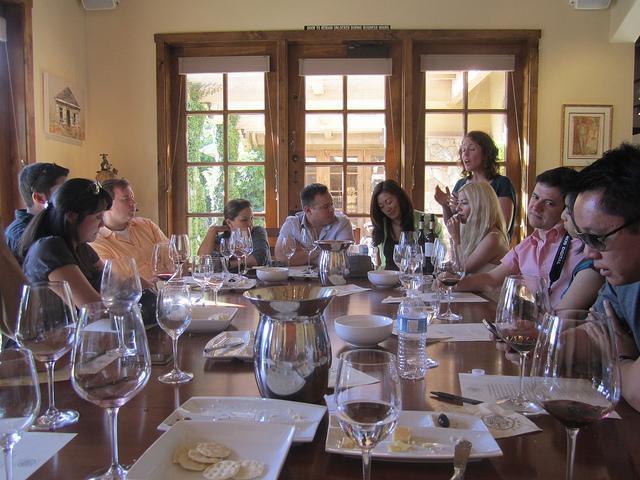How many windows are there?
Give a very brief answer. 3. How many people are in the picture?
Give a very brief answer. 10. How many wine glasses can be seen?
Give a very brief answer. 9. 